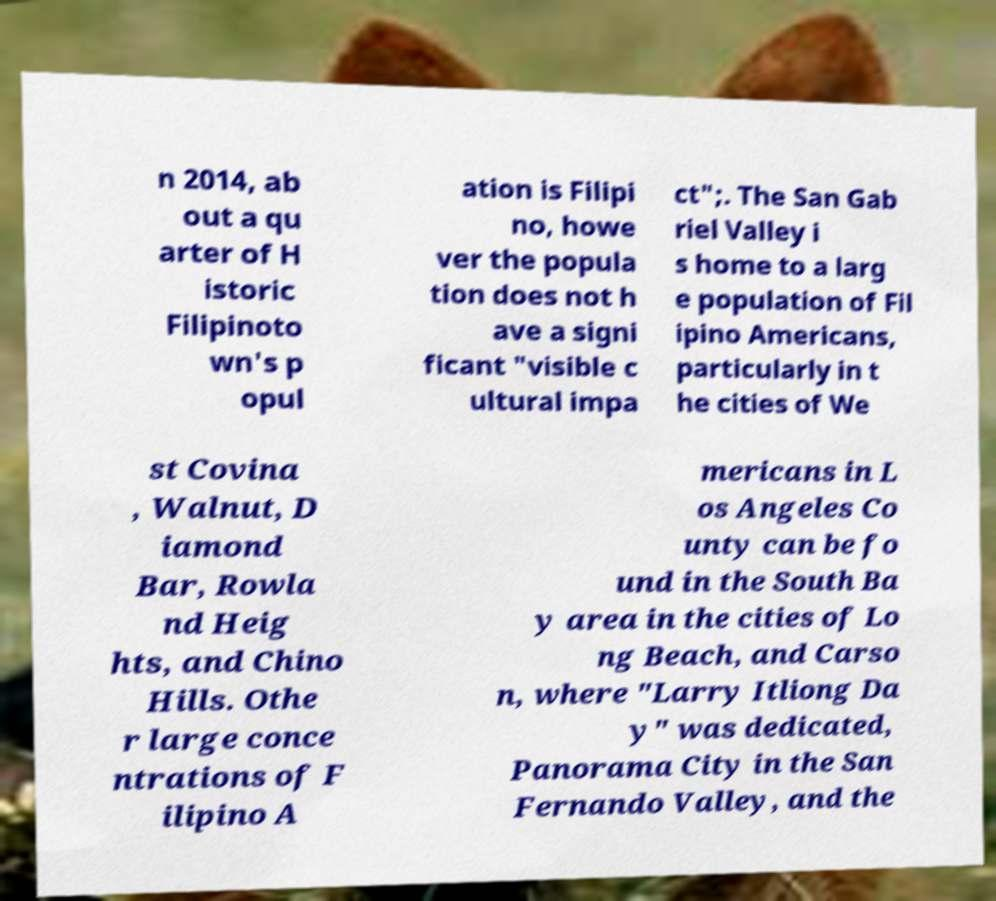Please identify and transcribe the text found in this image. n 2014, ab out a qu arter of H istoric Filipinoto wn's p opul ation is Filipi no, howe ver the popula tion does not h ave a signi ficant "visible c ultural impa ct";. The San Gab riel Valley i s home to a larg e population of Fil ipino Americans, particularly in t he cities of We st Covina , Walnut, D iamond Bar, Rowla nd Heig hts, and Chino Hills. Othe r large conce ntrations of F ilipino A mericans in L os Angeles Co unty can be fo und in the South Ba y area in the cities of Lo ng Beach, and Carso n, where "Larry Itliong Da y" was dedicated, Panorama City in the San Fernando Valley, and the 